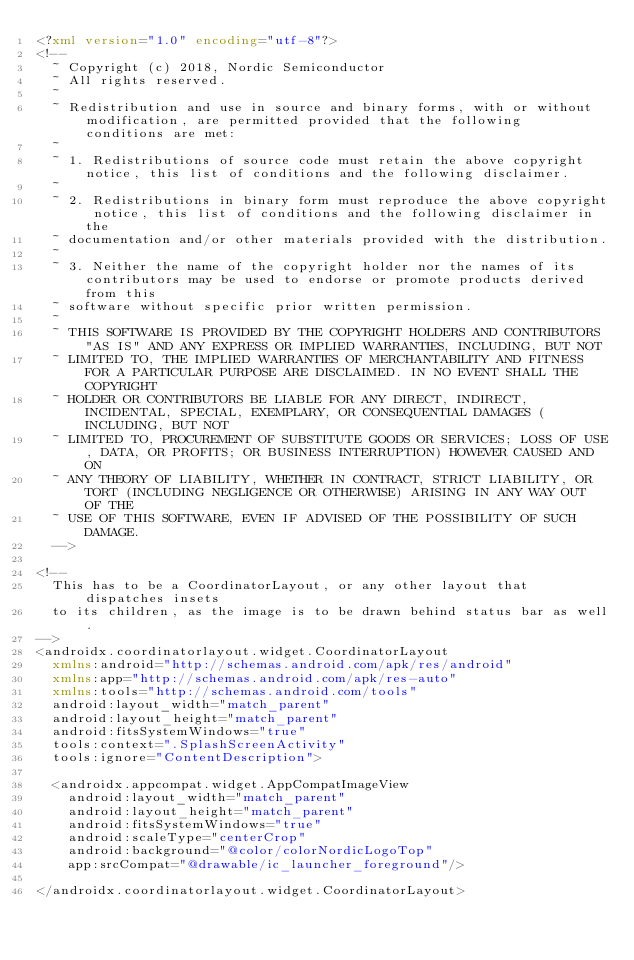Convert code to text. <code><loc_0><loc_0><loc_500><loc_500><_XML_><?xml version="1.0" encoding="utf-8"?>
<!--
  ~ Copyright (c) 2018, Nordic Semiconductor
  ~ All rights reserved.
  ~
  ~ Redistribution and use in source and binary forms, with or without modification, are permitted provided that the following conditions are met:
  ~
  ~ 1. Redistributions of source code must retain the above copyright notice, this list of conditions and the following disclaimer.
  ~
  ~ 2. Redistributions in binary form must reproduce the above copyright notice, this list of conditions and the following disclaimer in the
  ~ documentation and/or other materials provided with the distribution.
  ~
  ~ 3. Neither the name of the copyright holder nor the names of its contributors may be used to endorse or promote products derived from this
  ~ software without specific prior written permission.
  ~
  ~ THIS SOFTWARE IS PROVIDED BY THE COPYRIGHT HOLDERS AND CONTRIBUTORS "AS IS" AND ANY EXPRESS OR IMPLIED WARRANTIES, INCLUDING, BUT NOT
  ~ LIMITED TO, THE IMPLIED WARRANTIES OF MERCHANTABILITY AND FITNESS FOR A PARTICULAR PURPOSE ARE DISCLAIMED. IN NO EVENT SHALL THE COPYRIGHT
  ~ HOLDER OR CONTRIBUTORS BE LIABLE FOR ANY DIRECT, INDIRECT, INCIDENTAL, SPECIAL, EXEMPLARY, OR CONSEQUENTIAL DAMAGES (INCLUDING, BUT NOT
  ~ LIMITED TO, PROCUREMENT OF SUBSTITUTE GOODS OR SERVICES; LOSS OF USE, DATA, OR PROFITS; OR BUSINESS INTERRUPTION) HOWEVER CAUSED AND ON
  ~ ANY THEORY OF LIABILITY, WHETHER IN CONTRACT, STRICT LIABILITY, OR TORT (INCLUDING NEGLIGENCE OR OTHERWISE) ARISING IN ANY WAY OUT OF THE
  ~ USE OF THIS SOFTWARE, EVEN IF ADVISED OF THE POSSIBILITY OF SUCH DAMAGE.
  -->

<!--
	This has to be a CoordinatorLayout, or any other layout that dispatches insets
	to its children, as the image is to be drawn behind status bar as well.
-->
<androidx.coordinatorlayout.widget.CoordinatorLayout
	xmlns:android="http://schemas.android.com/apk/res/android"
	xmlns:app="http://schemas.android.com/apk/res-auto"
	xmlns:tools="http://schemas.android.com/tools"
	android:layout_width="match_parent"
	android:layout_height="match_parent"
	android:fitsSystemWindows="true"
	tools:context=".SplashScreenActivity"
	tools:ignore="ContentDescription">

	<androidx.appcompat.widget.AppCompatImageView
		android:layout_width="match_parent"
		android:layout_height="match_parent"
		android:fitsSystemWindows="true"
		android:scaleType="centerCrop"
		android:background="@color/colorNordicLogoTop"
		app:srcCompat="@drawable/ic_launcher_foreground"/>
	
</androidx.coordinatorlayout.widget.CoordinatorLayout>
</code> 